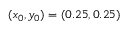Convert formula to latex. <formula><loc_0><loc_0><loc_500><loc_500>( x _ { 0 } , y _ { 0 } ) = ( 0 . 2 5 , 0 . 2 5 )</formula> 